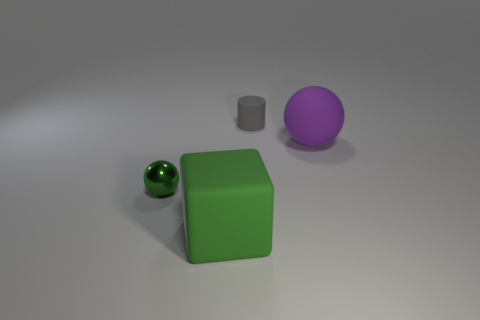Add 2 green rubber blocks. How many objects exist? 6 Add 4 tiny green rubber balls. How many tiny green rubber balls exist? 4 Subtract 0 cyan cubes. How many objects are left? 4 Subtract all cylinders. How many objects are left? 3 Subtract all large matte cubes. Subtract all green metal objects. How many objects are left? 2 Add 3 tiny gray objects. How many tiny gray objects are left? 4 